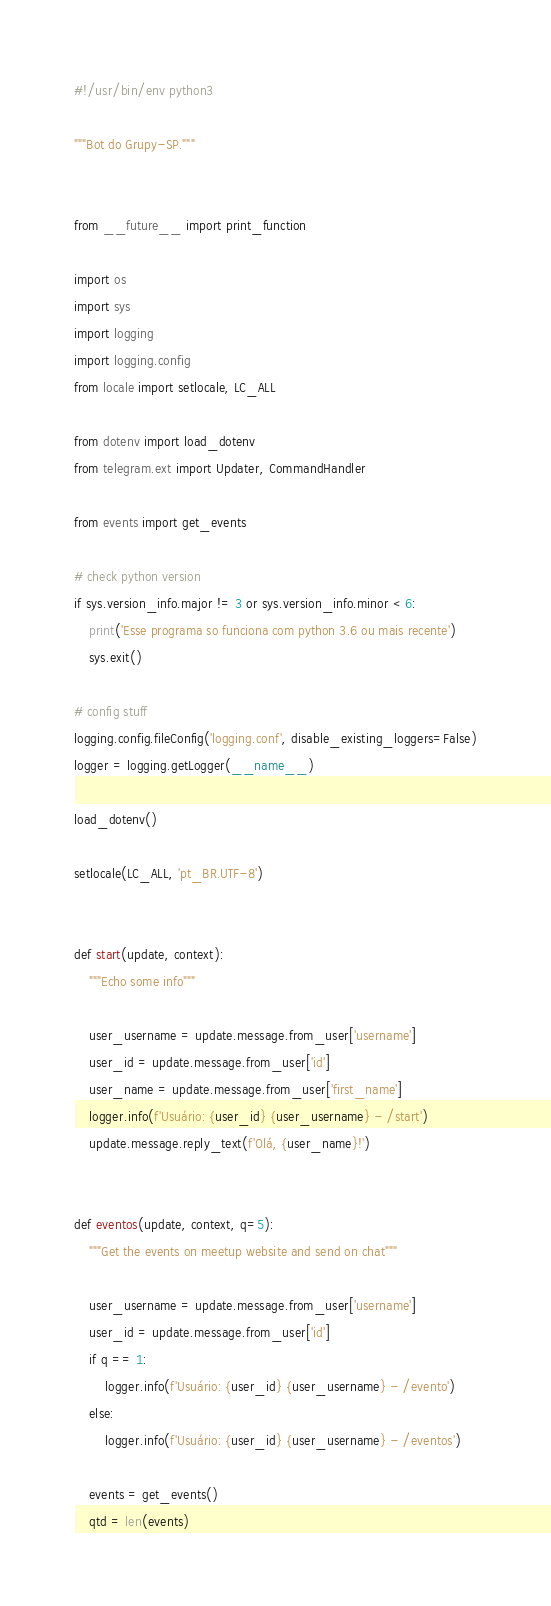Convert code to text. <code><loc_0><loc_0><loc_500><loc_500><_Python_>#!/usr/bin/env python3

"""Bot do Grupy-SP."""


from __future__ import print_function

import os
import sys
import logging
import logging.config
from locale import setlocale, LC_ALL

from dotenv import load_dotenv
from telegram.ext import Updater, CommandHandler

from events import get_events

# check python version
if sys.version_info.major != 3 or sys.version_info.minor < 6:
    print('Esse programa so funciona com python 3.6 ou mais recente')
    sys.exit()

# config stuff
logging.config.fileConfig('logging.conf', disable_existing_loggers=False)
logger = logging.getLogger(__name__)

load_dotenv()

setlocale(LC_ALL, 'pt_BR.UTF-8')


def start(update, context):
    """Echo some info"""

    user_username = update.message.from_user['username']
    user_id = update.message.from_user['id']
    user_name = update.message.from_user['first_name']
    logger.info(f'Usuário: {user_id} {user_username} - /start')
    update.message.reply_text(f'Olá, {user_name}!')


def eventos(update, context, q=5):
    """Get the events on meetup website and send on chat"""

    user_username = update.message.from_user['username']
    user_id = update.message.from_user['id']
    if q == 1:
        logger.info(f'Usuário: {user_id} {user_username} - /evento')
    else:
        logger.info(f'Usuário: {user_id} {user_username} - /eventos')

    events = get_events()
    qtd = len(events)
</code> 